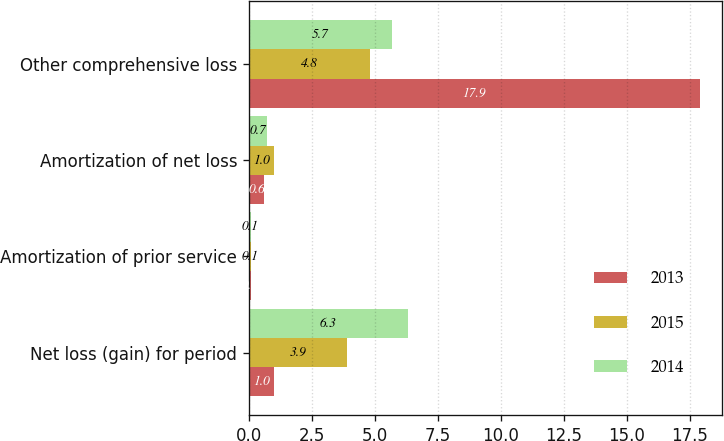Convert chart. <chart><loc_0><loc_0><loc_500><loc_500><stacked_bar_chart><ecel><fcel>Net loss (gain) for period<fcel>Amortization of prior service<fcel>Amortization of net loss<fcel>Other comprehensive loss<nl><fcel>2013<fcel>1<fcel>0.1<fcel>0.6<fcel>17.9<nl><fcel>2015<fcel>3.9<fcel>0.1<fcel>1<fcel>4.8<nl><fcel>2014<fcel>6.3<fcel>0.1<fcel>0.7<fcel>5.7<nl></chart> 